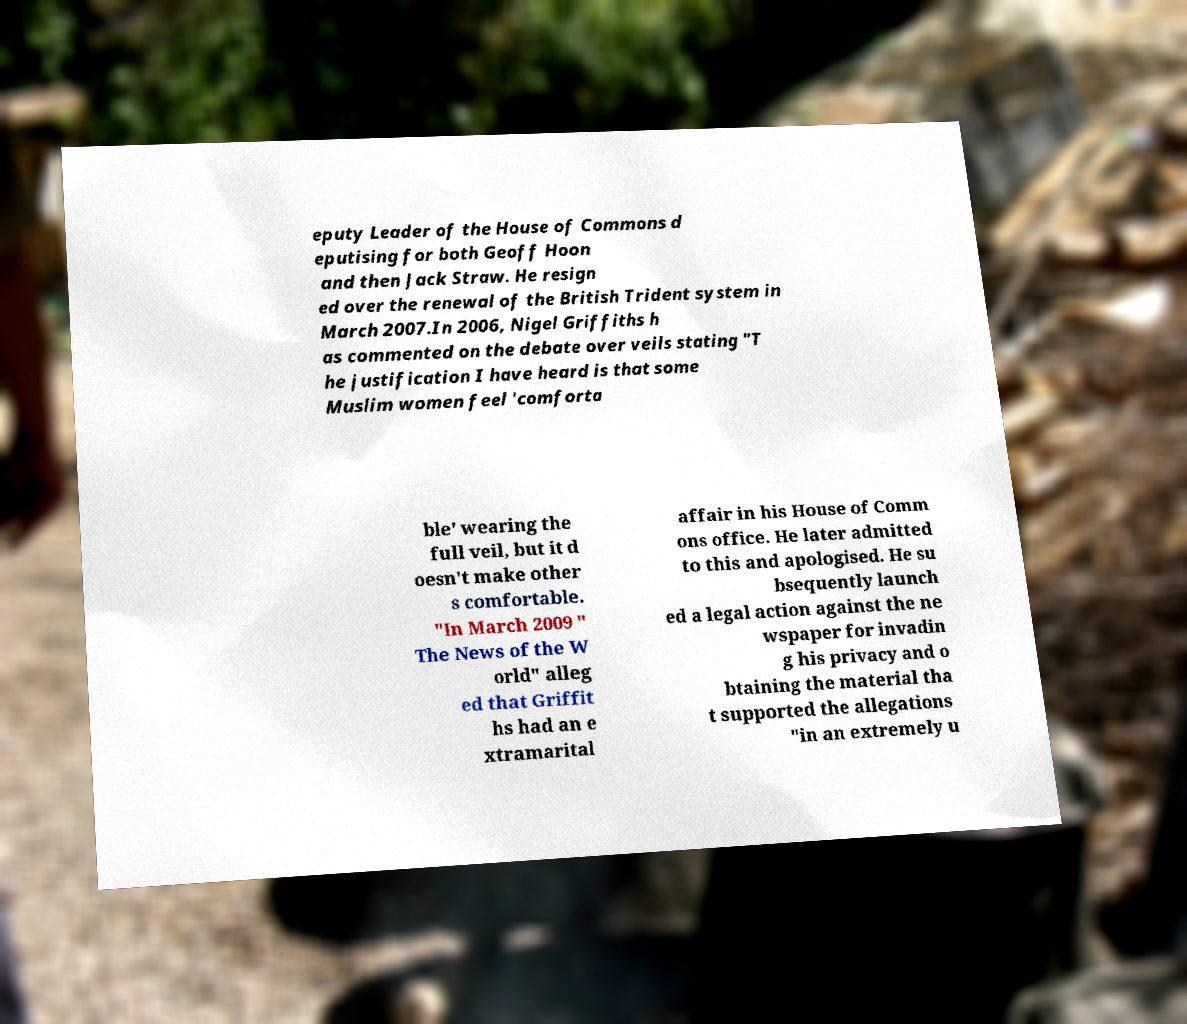There's text embedded in this image that I need extracted. Can you transcribe it verbatim? eputy Leader of the House of Commons d eputising for both Geoff Hoon and then Jack Straw. He resign ed over the renewal of the British Trident system in March 2007.In 2006, Nigel Griffiths h as commented on the debate over veils stating "T he justification I have heard is that some Muslim women feel 'comforta ble' wearing the full veil, but it d oesn't make other s comfortable. "In March 2009 " The News of the W orld" alleg ed that Griffit hs had an e xtramarital affair in his House of Comm ons office. He later admitted to this and apologised. He su bsequently launch ed a legal action against the ne wspaper for invadin g his privacy and o btaining the material tha t supported the allegations "in an extremely u 